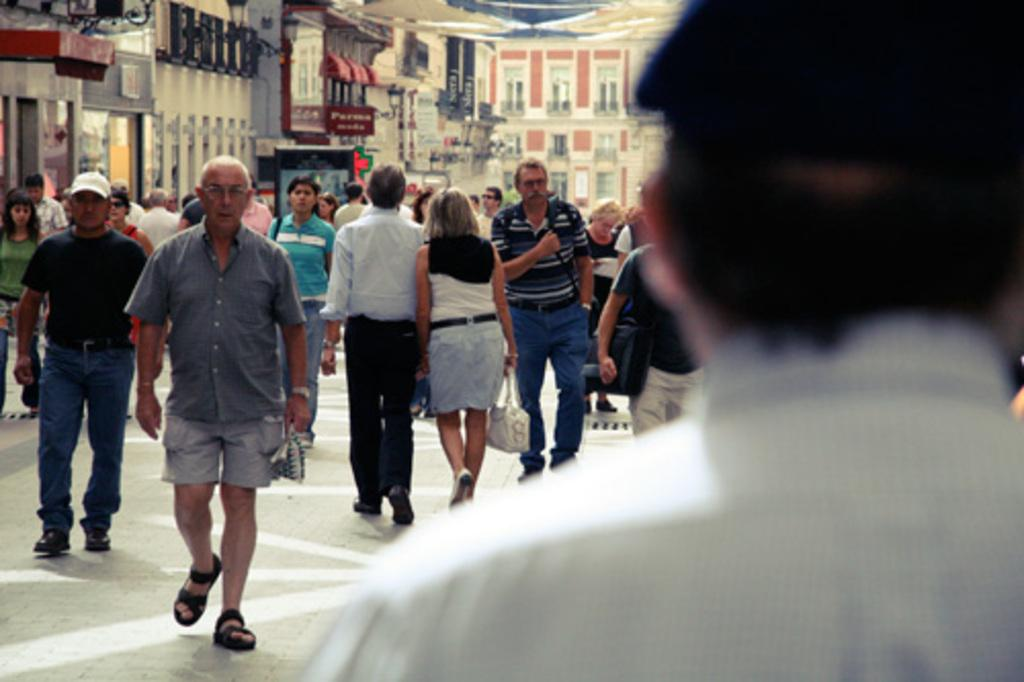Who or what is present in the image? There is a person in the image. What are the people in the image doing? There are people walking on the road in the image. What can be seen in the distance in the image? There are buildings and lights visible in the background of the image. What invention is being demonstrated by the person in the image? There is no invention being demonstrated in the image; it simply shows a person and people walking on the road. 